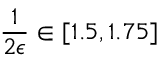<formula> <loc_0><loc_0><loc_500><loc_500>\frac { 1 } { 2 \epsilon } \in [ 1 . 5 , 1 . 7 5 ]</formula> 